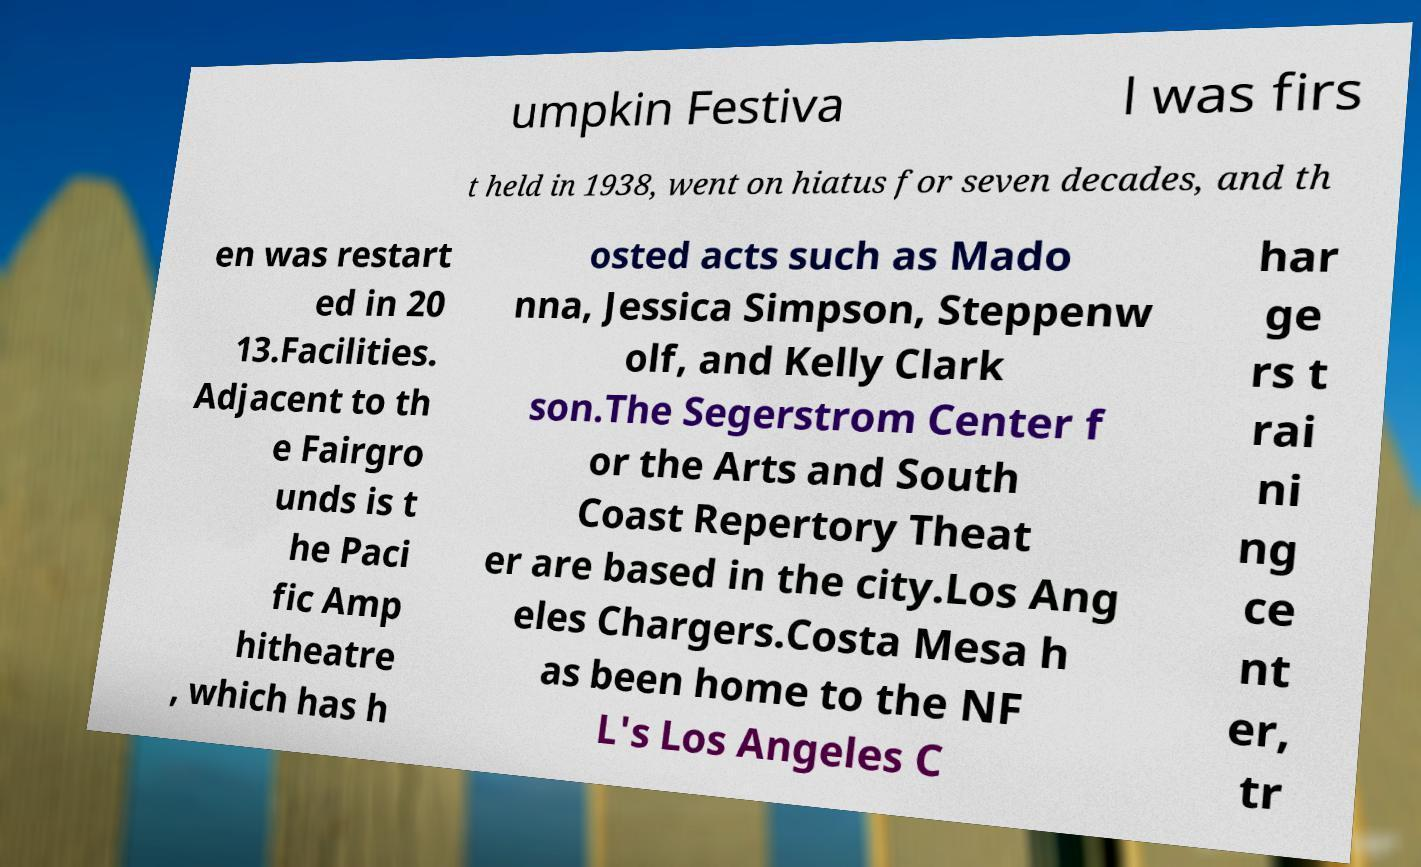Please read and relay the text visible in this image. What does it say? umpkin Festiva l was firs t held in 1938, went on hiatus for seven decades, and th en was restart ed in 20 13.Facilities. Adjacent to th e Fairgro unds is t he Paci fic Amp hitheatre , which has h osted acts such as Mado nna, Jessica Simpson, Steppenw olf, and Kelly Clark son.The Segerstrom Center f or the Arts and South Coast Repertory Theat er are based in the city.Los Ang eles Chargers.Costa Mesa h as been home to the NF L's Los Angeles C har ge rs t rai ni ng ce nt er, tr 